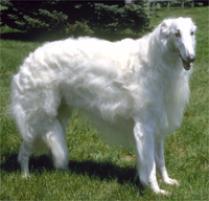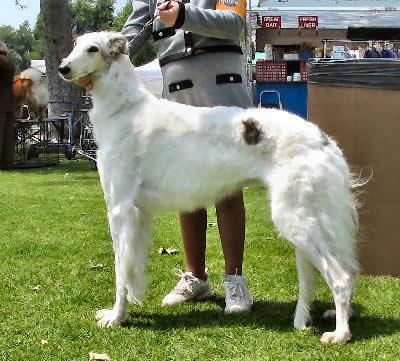The first image is the image on the left, the second image is the image on the right. For the images displayed, is the sentence "There is a human holding a dog's leash." factually correct? Answer yes or no. Yes. The first image is the image on the left, the second image is the image on the right. Given the left and right images, does the statement "In one of the images, a single white dog with no dark patches has its mouth open and is standing in green grass facing rightward." hold true? Answer yes or no. Yes. 